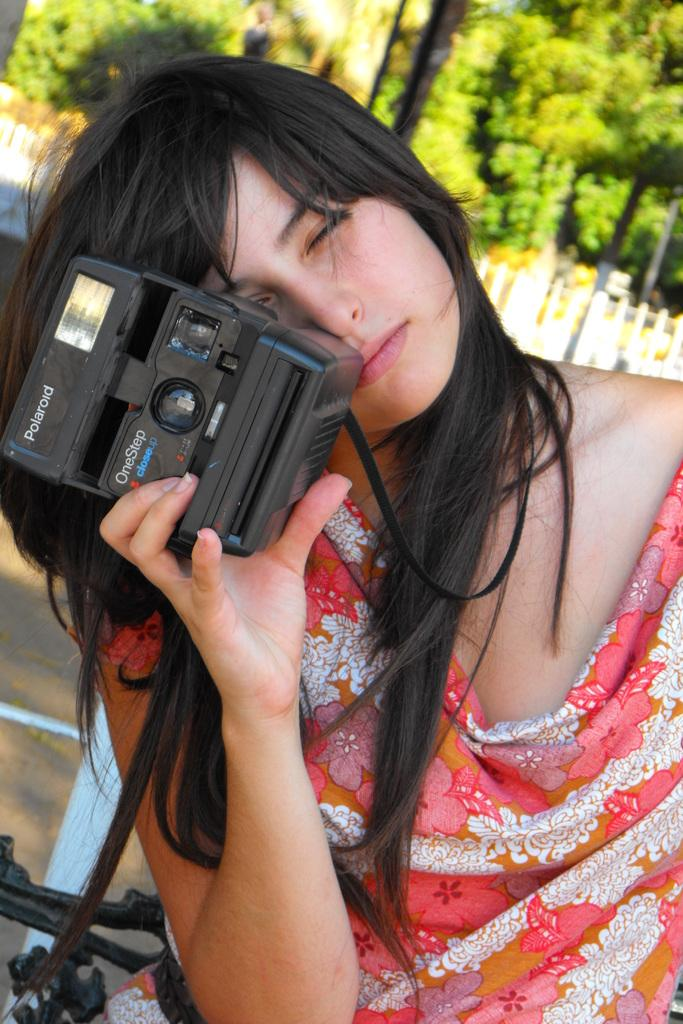Who is the main subject in the image? There is a woman in the image. What is the woman wearing? The woman is wearing an orange dress. What is the woman holding in the image? The woman is holding a camera. What can be seen in the background of the image? There are trees in the background of the image. What type of pancake is the woman eating during her hobbies in the image? There is no pancake present in the image, and the woman's hobbies are not mentioned. 